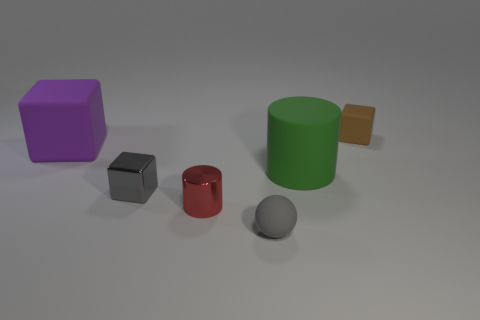Add 2 tiny gray rubber balls. How many objects exist? 8 Subtract all spheres. How many objects are left? 5 Add 3 small brown objects. How many small brown objects are left? 4 Add 1 green matte cylinders. How many green matte cylinders exist? 2 Subtract 0 cyan cylinders. How many objects are left? 6 Subtract all small blue shiny spheres. Subtract all tiny gray blocks. How many objects are left? 5 